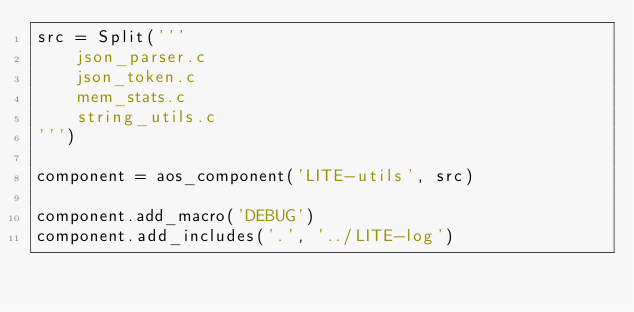<code> <loc_0><loc_0><loc_500><loc_500><_Python_>src = Split('''
    json_parser.c
    json_token.c
    mem_stats.c
    string_utils.c
''')

component = aos_component('LITE-utils', src)

component.add_macro('DEBUG')
component.add_includes('.', '../LITE-log')
</code> 